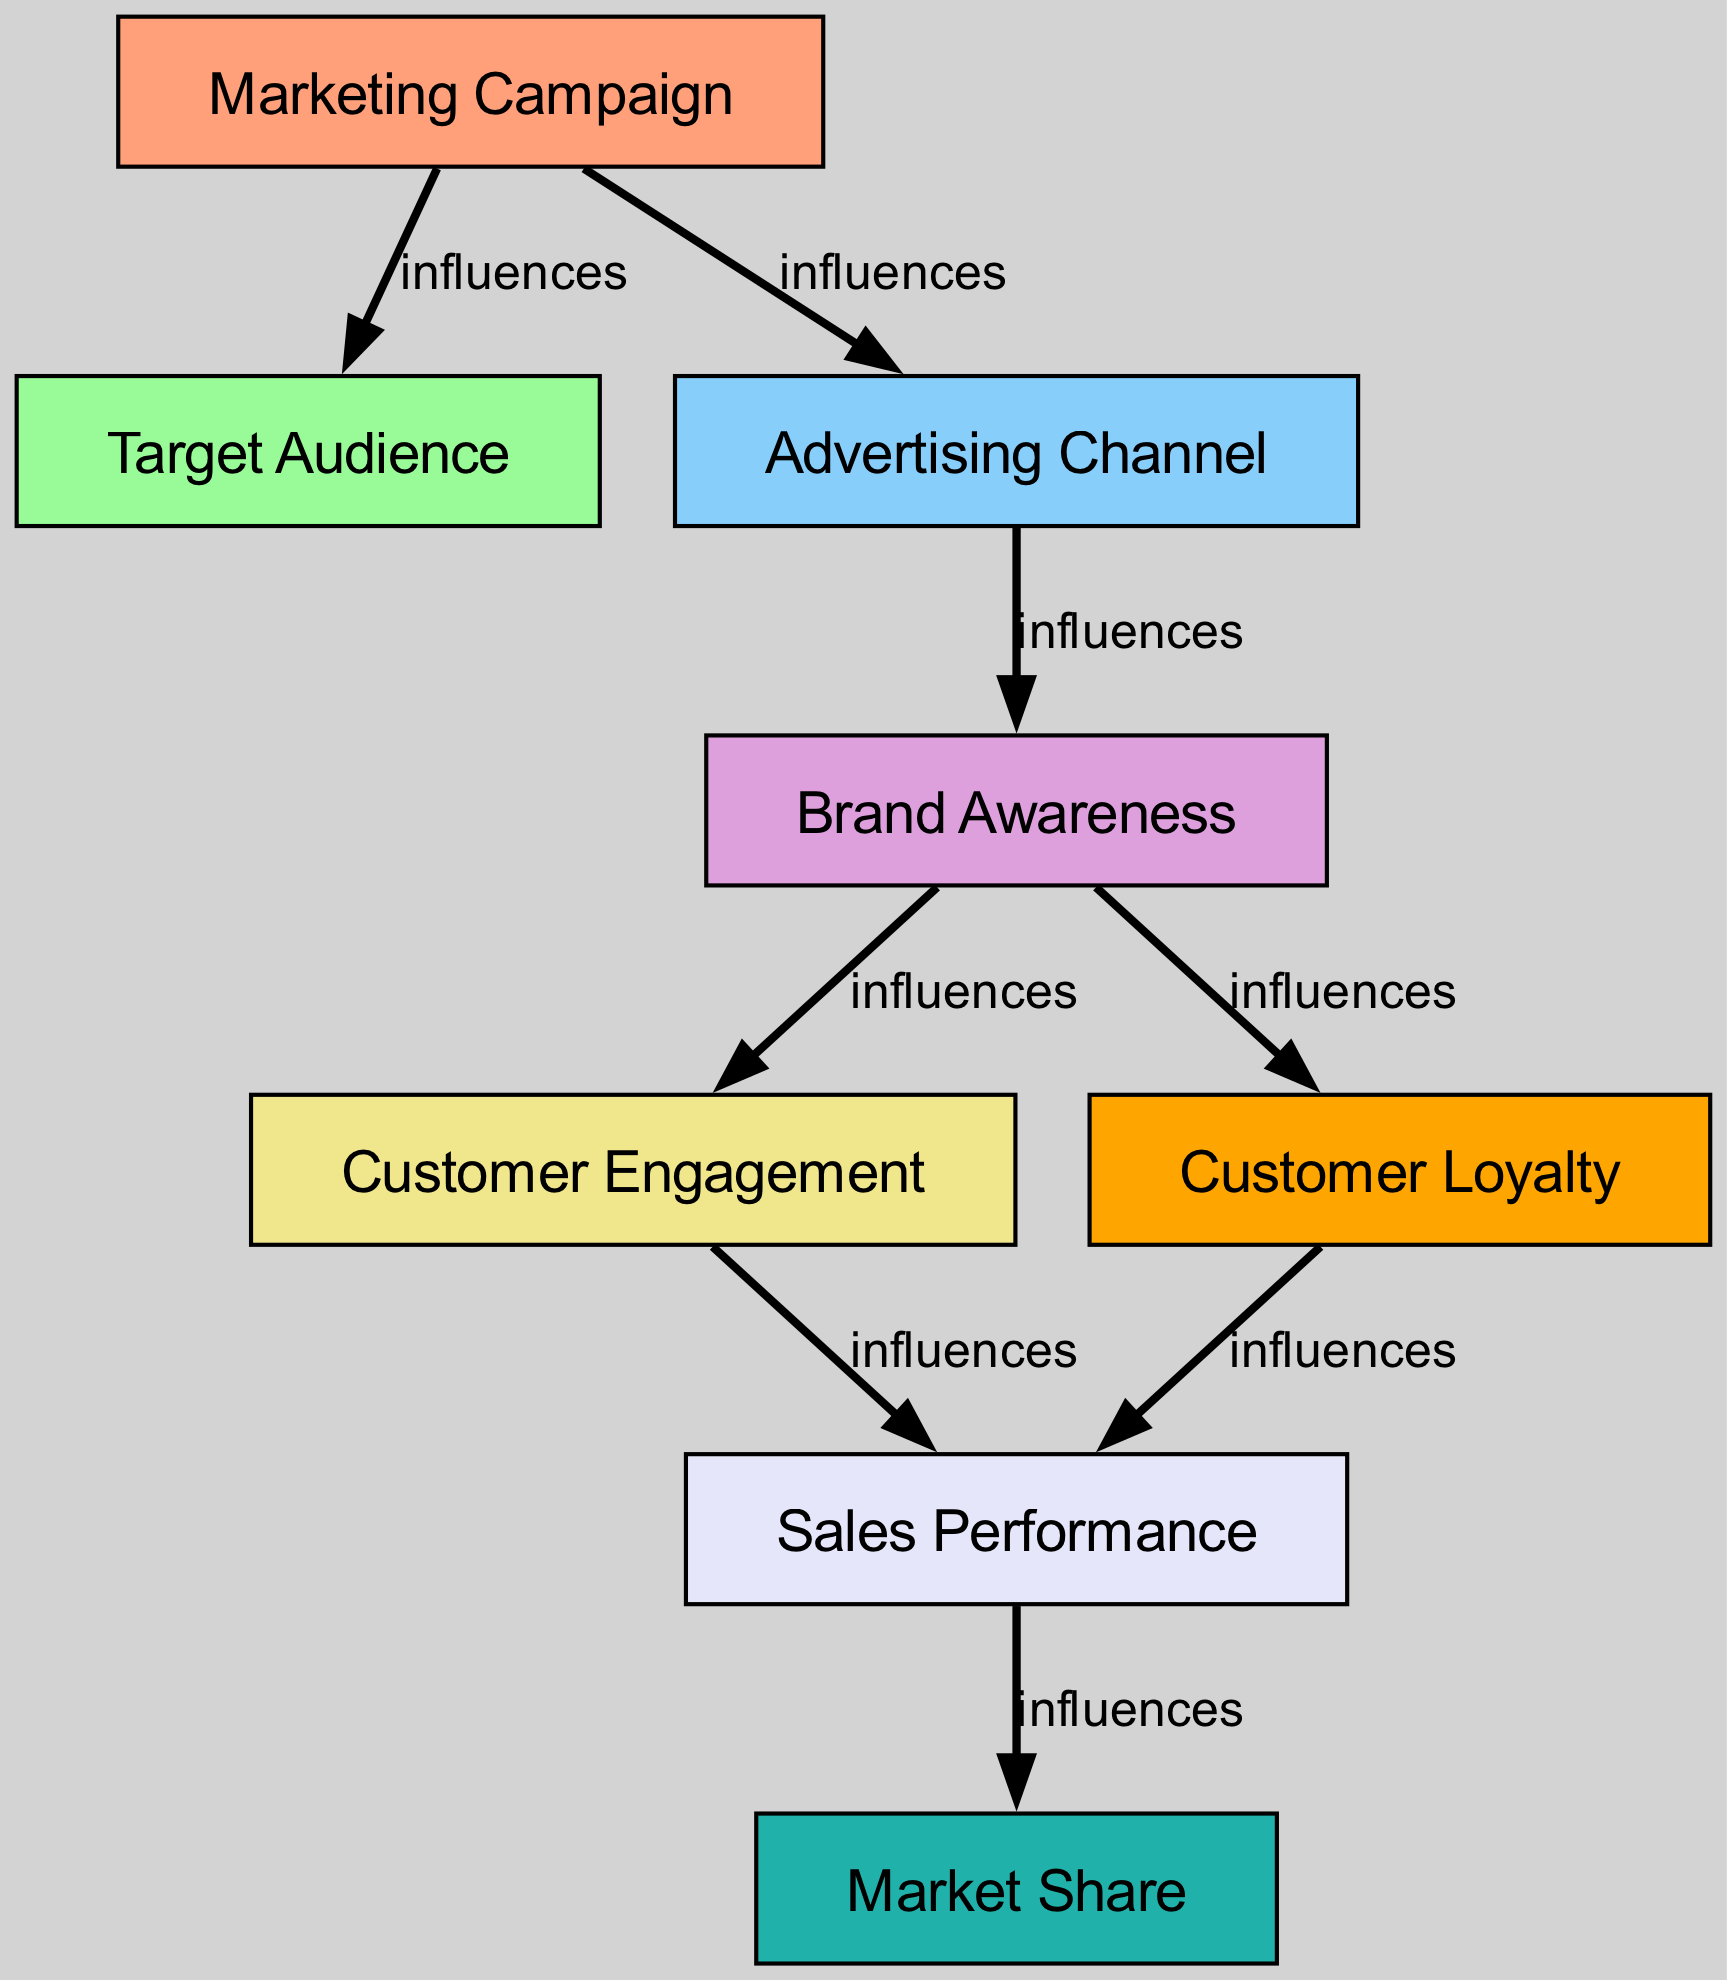What is the total number of nodes in the diagram? The diagram lists 8 unique entities as nodes: Marketing Campaign, Target Audience, Advertising Channel, Brand Awareness, Customer Engagement, Sales Performance, Market Share, and Customer Loyalty. Counting these gives a total of 8.
Answer: 8 Which node influences Customer Engagement? Tracing the edges from nodes connected to Customer Engagement, we see that it is influenced by Brand Awareness, which indicates that an increase in Brand Awareness leads to higher Customer Engagement levels.
Answer: Brand Awareness How many edges are connected to Sales Performance? Analyzing the diagram, Sales Performance has two incoming edges (from Customer Engagement and Customer Loyalty) and one outgoing edge (to Market Share), resulting in a total of three edges connected to it.
Answer: 3 What influences Customer Loyalty directly? The diagram shows only one direct influence on Customer Loyalty, which is Brand Awareness. This means that the level of Brand Awareness has a direct impact on Customer Loyalty without any intermediary nodes.
Answer: Brand Awareness Which node has the most outgoing edges? By observing the edges in the diagram, we can see that Brand Awareness has two outgoing edges leading to both Customer Engagement and Customer Loyalty, more than any other node.
Answer: Brand Awareness What is the relationship between Marketing Campaign and Market Share? The Marketing Campaign influences Market Share indirectly through a series of steps: it affects Target Audience and Advertising Channel, which lead to Brand Awareness, then Customer Engagement, Sales Performance, and finally, Market Share itself. Thus, the relationship is indirect.
Answer: Indirect Which node is the starting point of this directed graph? In directed graphs, the starting point is typically the node with no incoming edges. Here, Marketing Campaign has no edges coming into it, indicating it is the initial node from which the analysis begins.
Answer: Marketing Campaign How many nodes influence Market Share? Market Share is influenced by exactly two nodes: Sales Performance, which derives its influence from Customer Engagement, and ultimately the Marketing Campaign indirectly through several intermediary nodes. Thus, the count of direct influences leads to the conclusion of two influences.
Answer: 2 